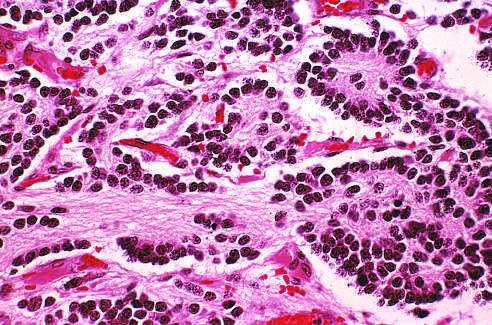s a homer-wright pseudorosette seen in the upper right corner?
Answer the question using a single word or phrase. Yes 